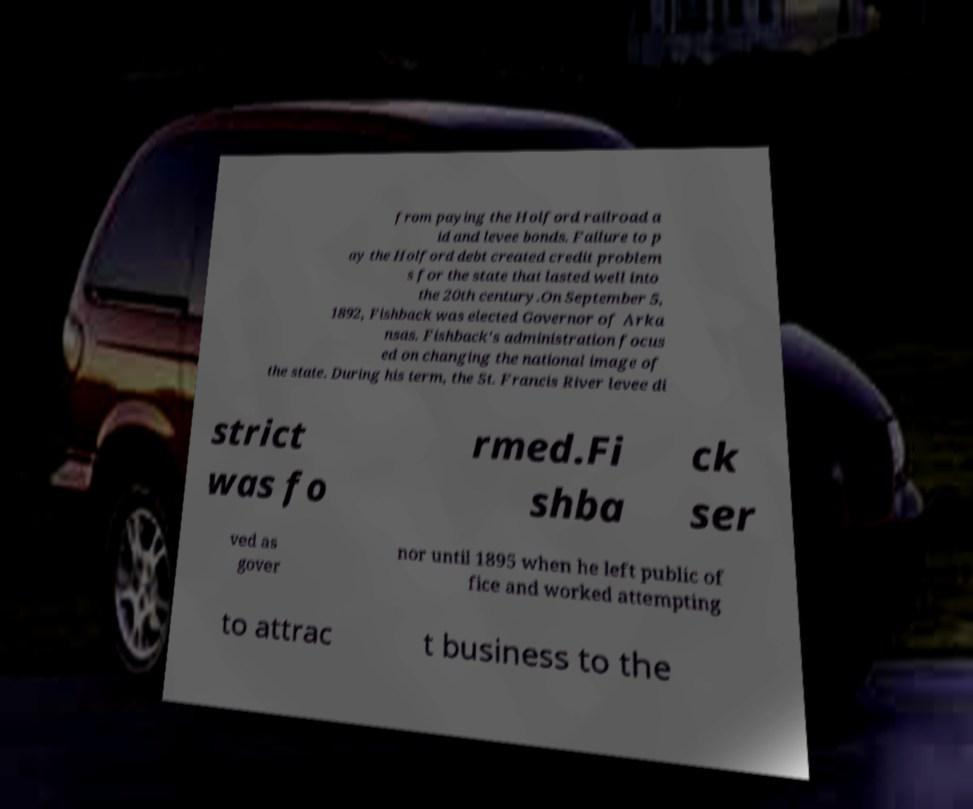Please read and relay the text visible in this image. What does it say? from paying the Holford railroad a id and levee bonds. Failure to p ay the Holford debt created credit problem s for the state that lasted well into the 20th century.On September 5, 1892, Fishback was elected Governor of Arka nsas. Fishback's administration focus ed on changing the national image of the state. During his term, the St. Francis River levee di strict was fo rmed.Fi shba ck ser ved as gover nor until 1895 when he left public of fice and worked attempting to attrac t business to the 